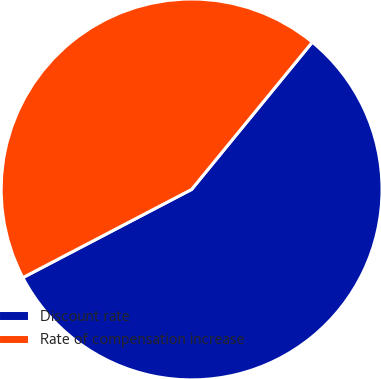<chart> <loc_0><loc_0><loc_500><loc_500><pie_chart><fcel>Discount rate<fcel>Rate of compensation increase<nl><fcel>56.41%<fcel>43.59%<nl></chart> 